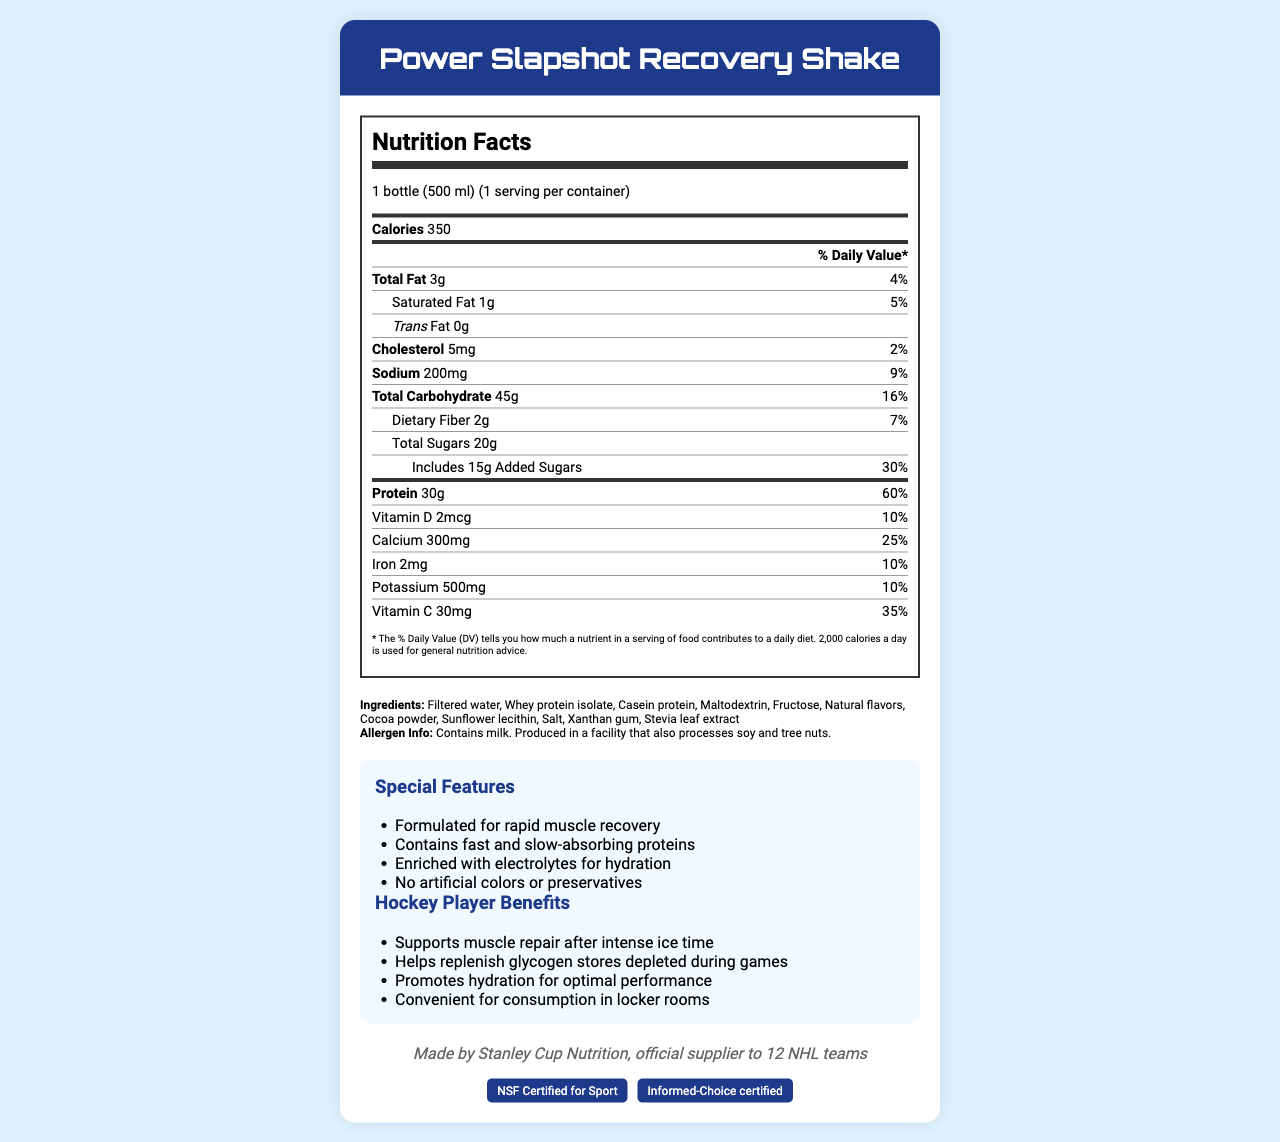what is the serving size of the Power Slapshot Recovery Shake? The serving size is listed at the top of the Nutrition Facts label.
Answer: 1 bottle (500 ml) how many calories are in one serving of this shake? The number of calories per serving is prominently displayed at the top of the nutrition information section.
Answer: 350 how much protein does the shake contain per serving? The amount of protein per serving is listed towards the bottom of the nutrition information.
Answer: 30g what is the percentage of daily value for sodium? The percentage of daily value for sodium is listed under the sodium nutrition facts.
Answer: 9% what are the first three ingredients listed for the shake? The first three ingredients can be found in the ingredients section towards the bottom of the document.
Answer: Filtered water, Whey protein isolate, Casein protein what is the total fat content per serving? The total fat content per serving is clearly listed near the top of the nutrition information.
Answer: 3g what percentage of daily value of calcium does the shake provide? A. 25% B. 10% C. 35% The percentage of the daily value for calcium is 25% as stated near the end of the nutrition facts.
Answer: A which of the following certifications does the shake have? I. NSF Certified for Sport II. USDA Organic III. Informed-Choice certified The document states the shake is NSF Certified for Sport and Informed-Choice certified.
Answer: I and III does the Power Slapshot Recovery Shake contain artificial colors or preservatives? The features section mentions that the shake contains no artificial colors or preservatives.
Answer: No is this product formulated for rapid muscle recovery? The special features section indicates that it is formulated for rapid muscle recovery.
Answer: Yes summarize the main purpose and benefits of the Power Slapshot Recovery Shake The shake's features and benefits, as outlined in the document, focus on muscle repair, nutrient replenishment, hydration, and convenience, especially for hockey players.
Answer: The Power Slapshot Recovery Shake is designed to support post-training muscle repair by providing high protein content and key nutrients, replenishing glycogen stores, and promoting hydration for optimal performance. It is easy to consume and comes with certifications to ensure its quality. how much total carbohydrate is in one serving? The total carbohydrate amount is listed under the nutrition facts.
Answer: 45g what is the amount of added sugars in the shake? The added sugars amount is specifically listed in the nutritional section.
Answer: 15g can I determine how the flavor of the shake is? The document does not provide specific details about the flavor profile of the shake beyond mentioning natural flavors; it mainly focuses on nutritional content and benefits.
Answer: Not enough information 